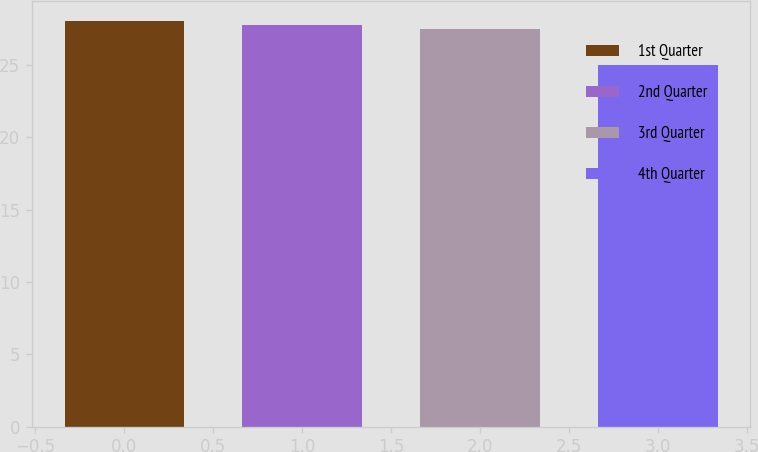Convert chart to OTSL. <chart><loc_0><loc_0><loc_500><loc_500><bar_chart><fcel>1st Quarter<fcel>2nd Quarter<fcel>3rd Quarter<fcel>4th Quarter<nl><fcel>28<fcel>27.72<fcel>27.44<fcel>25.02<nl></chart> 